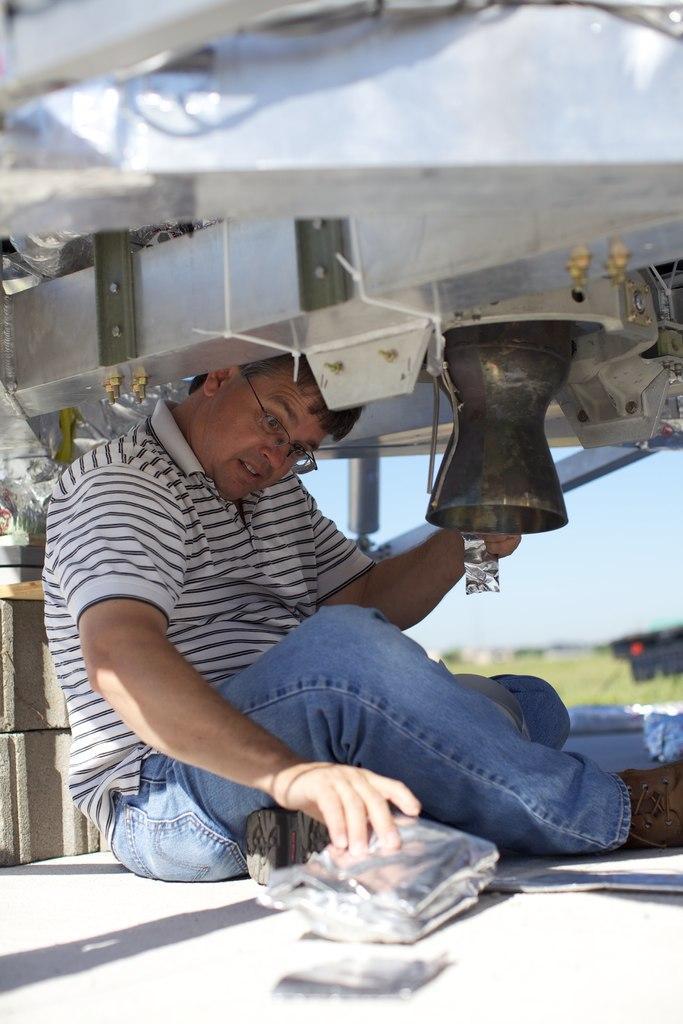Please provide a concise description of this image. In this picture we can see a man holding some objects and sitting on the ground. At the top of the man, there are some objects. Behind the man, there is grass and the sky. 